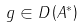Convert formula to latex. <formula><loc_0><loc_0><loc_500><loc_500>g \in D \left ( A ^ { * } \right )</formula> 